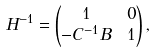Convert formula to latex. <formula><loc_0><loc_0><loc_500><loc_500>H ^ { - 1 } & = \begin{pmatrix} 1 & 0 \\ - C ^ { - 1 } B & 1 \end{pmatrix} ,</formula> 